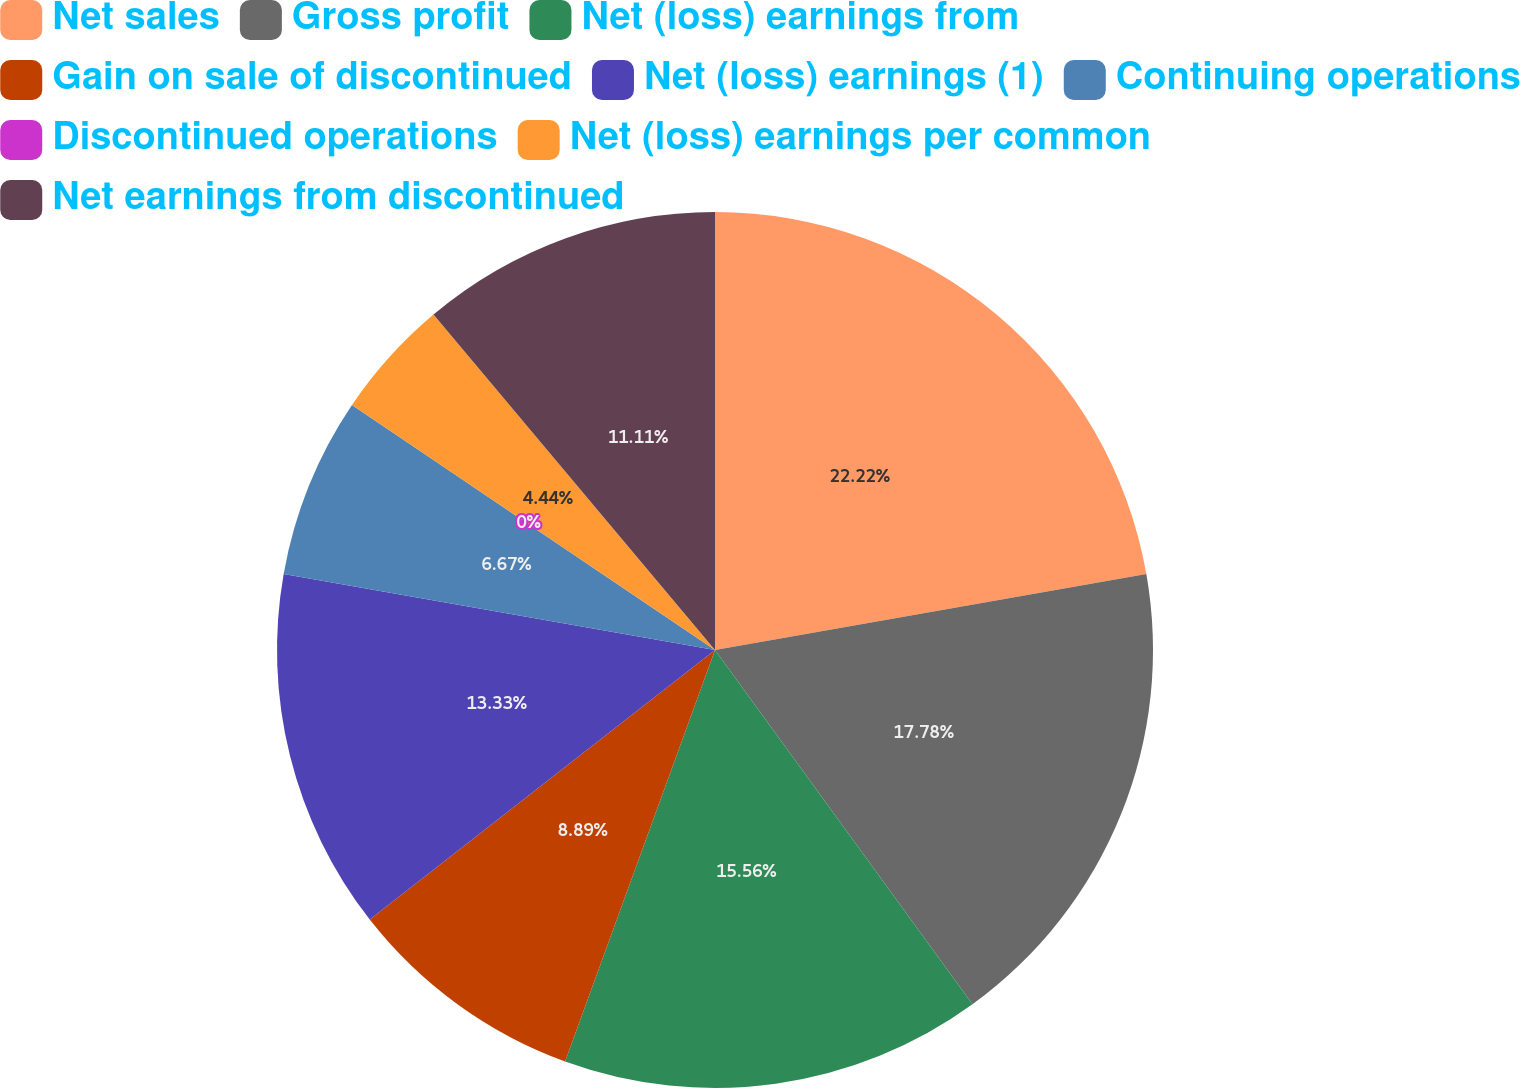Convert chart to OTSL. <chart><loc_0><loc_0><loc_500><loc_500><pie_chart><fcel>Net sales<fcel>Gross profit<fcel>Net (loss) earnings from<fcel>Gain on sale of discontinued<fcel>Net (loss) earnings (1)<fcel>Continuing operations<fcel>Discontinued operations<fcel>Net (loss) earnings per common<fcel>Net earnings from discontinued<nl><fcel>22.22%<fcel>17.78%<fcel>15.56%<fcel>8.89%<fcel>13.33%<fcel>6.67%<fcel>0.0%<fcel>4.44%<fcel>11.11%<nl></chart> 